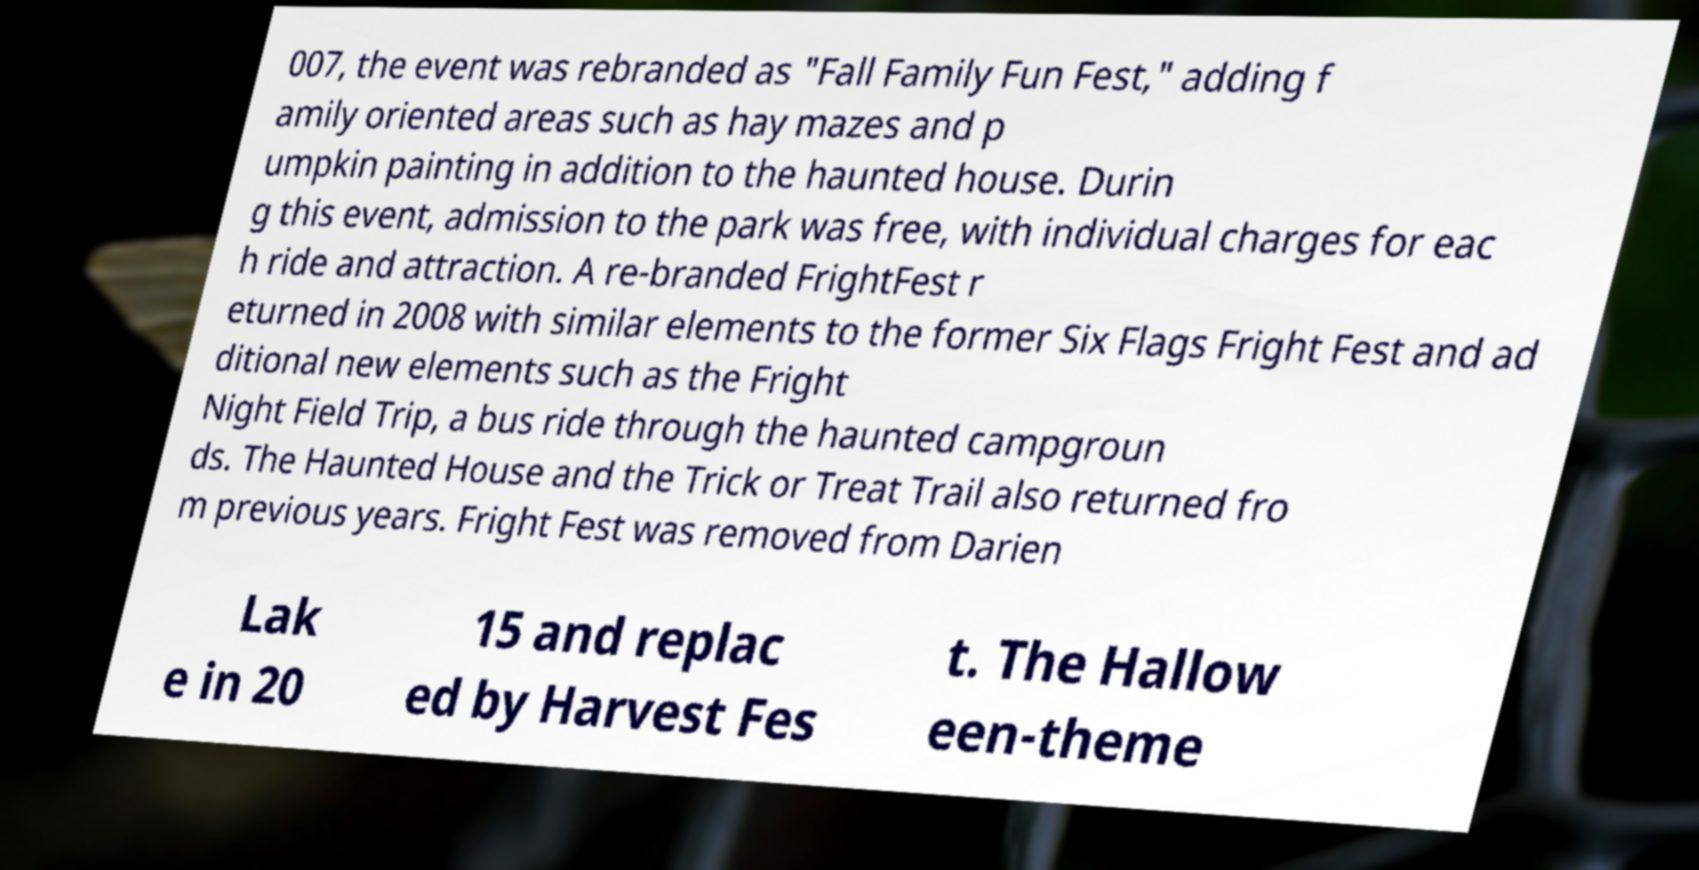Could you extract and type out the text from this image? 007, the event was rebranded as "Fall Family Fun Fest," adding f amily oriented areas such as hay mazes and p umpkin painting in addition to the haunted house. Durin g this event, admission to the park was free, with individual charges for eac h ride and attraction. A re-branded FrightFest r eturned in 2008 with similar elements to the former Six Flags Fright Fest and ad ditional new elements such as the Fright Night Field Trip, a bus ride through the haunted campgroun ds. The Haunted House and the Trick or Treat Trail also returned fro m previous years. Fright Fest was removed from Darien Lak e in 20 15 and replac ed by Harvest Fes t. The Hallow een-theme 